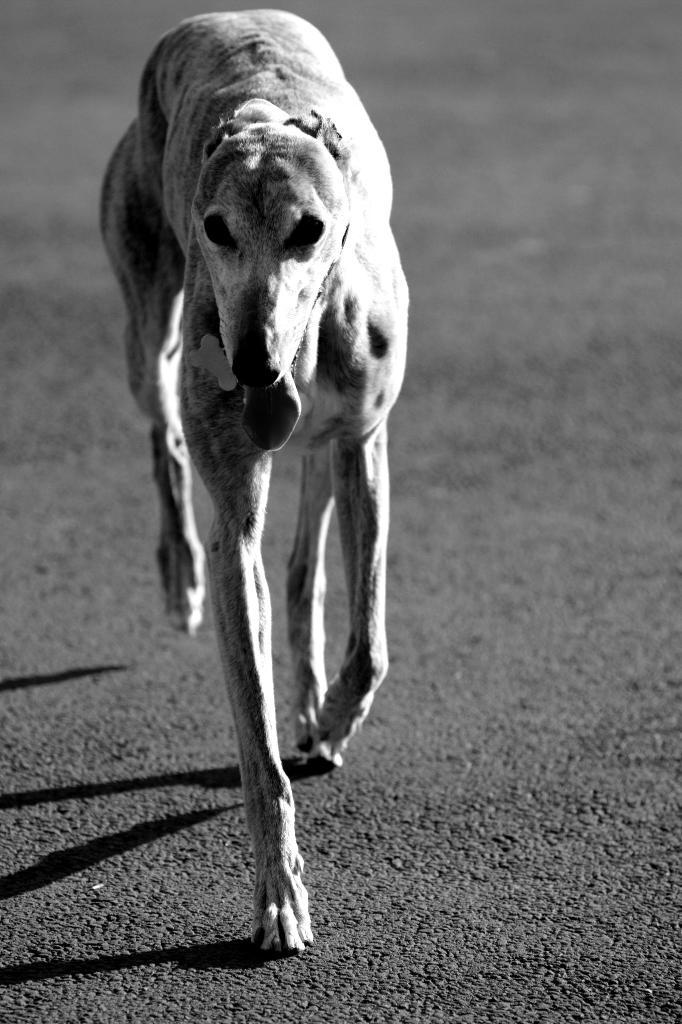What type of animal is in the image? There is a dog in the image. Where is the dog located? The dog is on the ground. What is the color scheme of the image? The image is in black and white. What type of scale can be seen in the image? There is no scale present in the image; it features a dog on the ground in black and white. How does the dog interact with its friend in the image? There is no friend present in the image; it only features a dog on the ground in black and white. 